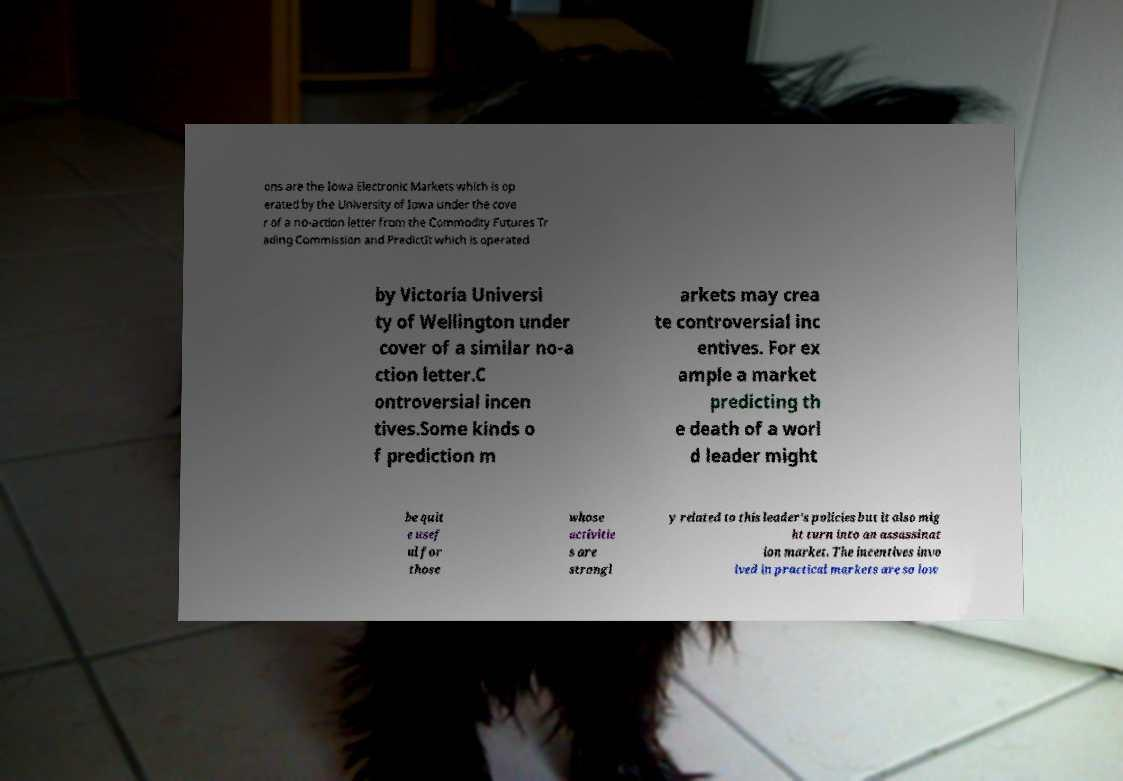For documentation purposes, I need the text within this image transcribed. Could you provide that? ons are the Iowa Electronic Markets which is op erated by the University of Iowa under the cove r of a no-action letter from the Commodity Futures Tr ading Commission and PredictIt which is operated by Victoria Universi ty of Wellington under cover of a similar no-a ction letter.C ontroversial incen tives.Some kinds o f prediction m arkets may crea te controversial inc entives. For ex ample a market predicting th e death of a worl d leader might be quit e usef ul for those whose activitie s are strongl y related to this leader's policies but it also mig ht turn into an assassinat ion market. The incentives invo lved in practical markets are so low 